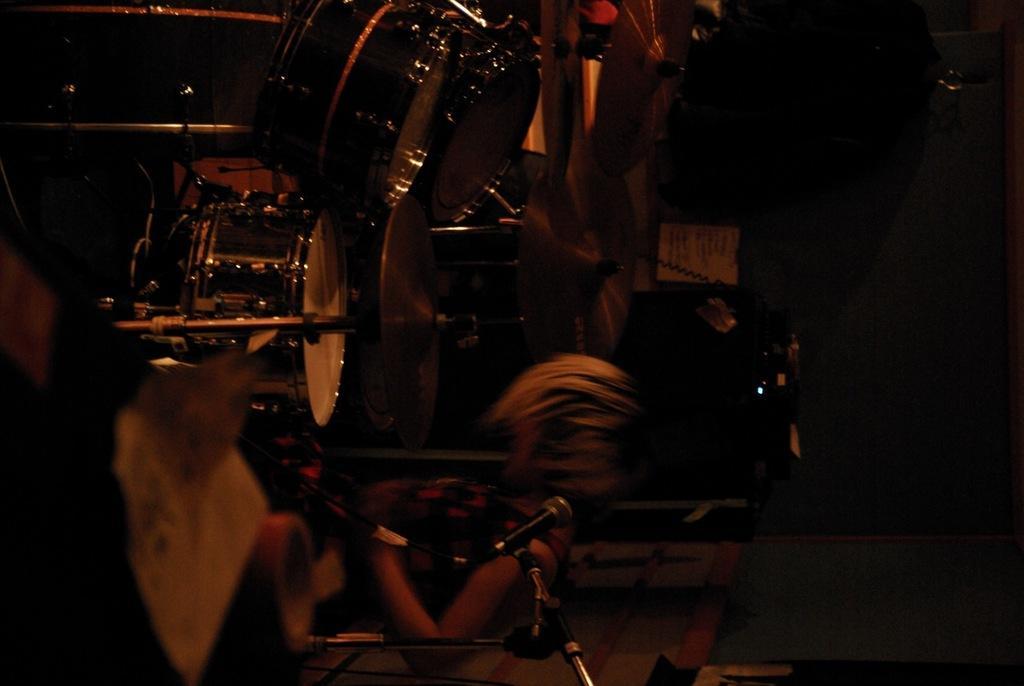How would you summarize this image in a sentence or two? In this picture I can see there is a person standing and playing the drum set and there are cymbals attached to the drum set. 